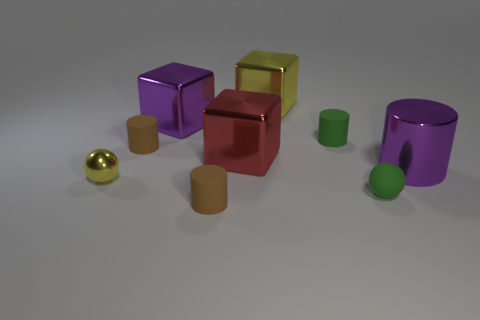Subtract 1 cylinders. How many cylinders are left? 3 Subtract all balls. How many objects are left? 7 Add 7 metallic balls. How many metallic balls are left? 8 Add 4 big cyan matte spheres. How many big cyan matte spheres exist? 4 Subtract 0 brown blocks. How many objects are left? 9 Subtract all green things. Subtract all purple shiny things. How many objects are left? 5 